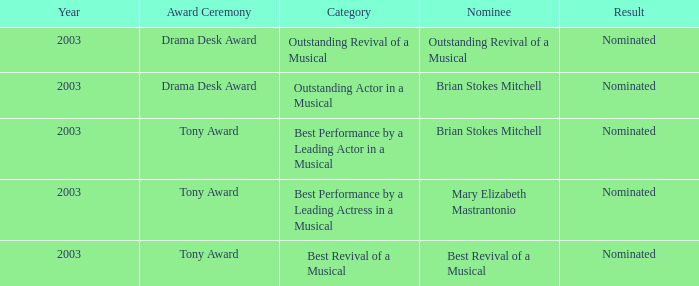What was the result for the nomination of Best Revival of a Musical? Nominated. 